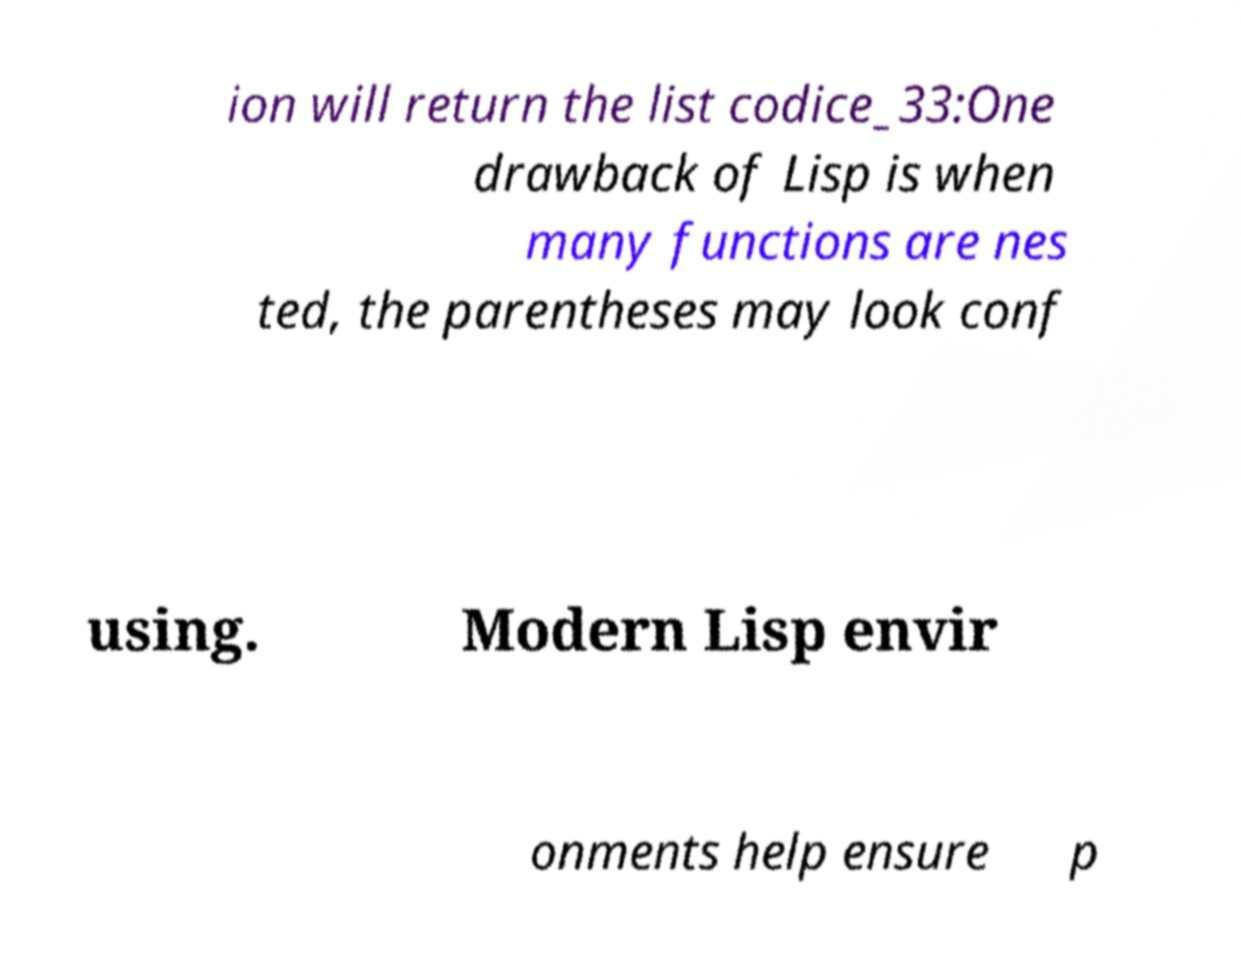Can you read and provide the text displayed in the image?This photo seems to have some interesting text. Can you extract and type it out for me? ion will return the list codice_33:One drawback of Lisp is when many functions are nes ted, the parentheses may look conf using. Modern Lisp envir onments help ensure p 